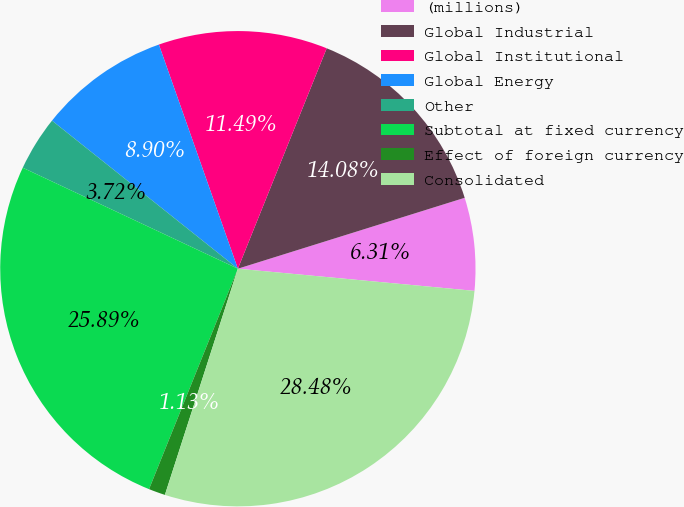<chart> <loc_0><loc_0><loc_500><loc_500><pie_chart><fcel>(millions)<fcel>Global Industrial<fcel>Global Institutional<fcel>Global Energy<fcel>Other<fcel>Subtotal at fixed currency<fcel>Effect of foreign currency<fcel>Consolidated<nl><fcel>6.31%<fcel>14.08%<fcel>11.49%<fcel>8.9%<fcel>3.72%<fcel>25.89%<fcel>1.13%<fcel>28.48%<nl></chart> 